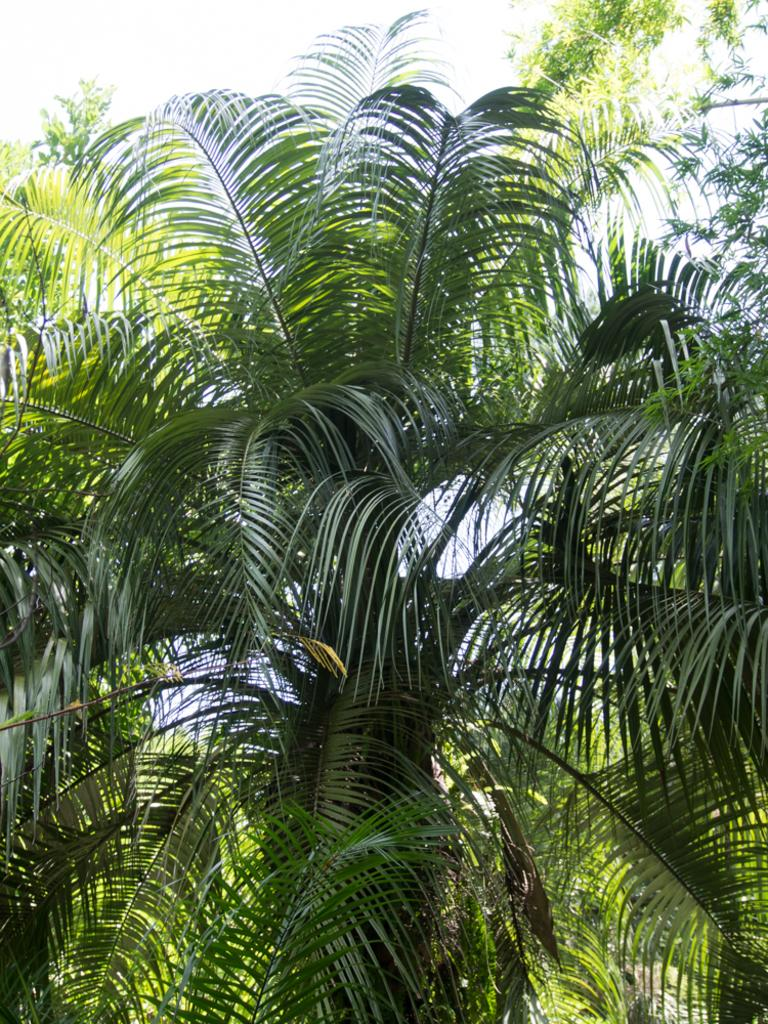What type of vegetation can be seen in the image? There are trees in the image. What part of the natural environment is visible in the image? The sky is visible in the image. What type of skirt is hanging from the tree in the image? There is no skirt present in the image; it only features trees and the sky. Can you tell me how many engines are visible in the image? There are no engines present in the image. 